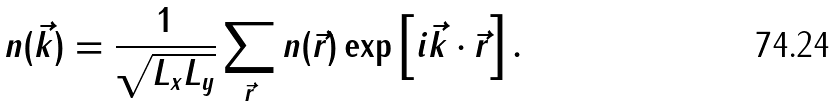Convert formula to latex. <formula><loc_0><loc_0><loc_500><loc_500>n ( \vec { k } ) = \frac { 1 } { \sqrt { L _ { x } L _ { y } } } \sum _ { \vec { r } } n ( \vec { r } ) \exp \left [ i \vec { k } \cdot \vec { r } \right ] .</formula> 